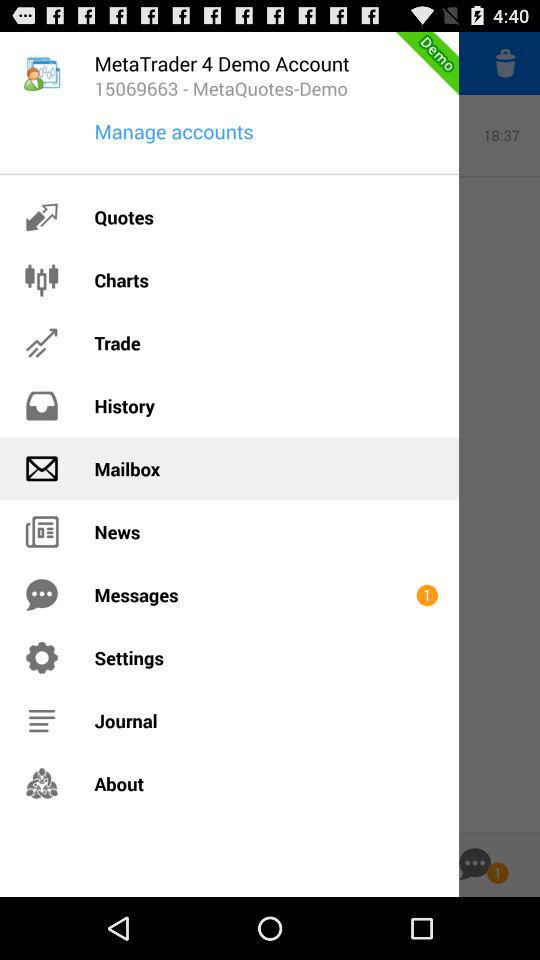What is the "MetaTrader 4" demo account number? The "MetaTrader 4" demo account number is 15069663. 